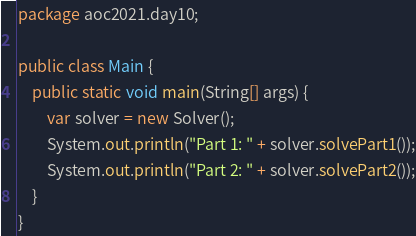<code> <loc_0><loc_0><loc_500><loc_500><_Java_>package aoc2021.day10;

public class Main {
    public static void main(String[] args) {
        var solver = new Solver();
        System.out.println("Part 1: " + solver.solvePart1());
        System.out.println("Part 2: " + solver.solvePart2());
    }
}
</code> 